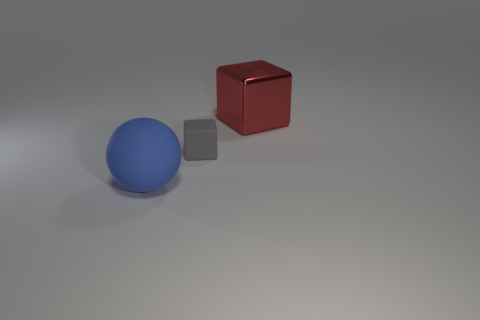Is there any other thing that is the same material as the big red block?
Offer a very short reply. No. Is there anything else that is the same size as the gray rubber cube?
Give a very brief answer. No. There is a object that is in front of the matte object that is behind the blue ball; what size is it?
Your answer should be compact. Large. Are there any big matte objects of the same color as the big cube?
Offer a very short reply. No. Are there an equal number of tiny gray matte blocks that are behind the small rubber thing and blue objects?
Keep it short and to the point. No. How many blue matte balls are there?
Give a very brief answer. 1. What is the shape of the thing that is to the left of the large shiny block and behind the blue sphere?
Ensure brevity in your answer.  Cube. There is a rubber object to the right of the big rubber sphere; is its color the same as the large object left of the big red block?
Make the answer very short. No. Are there any big red blocks that have the same material as the small gray block?
Your response must be concise. No. Are there an equal number of things that are on the left side of the metallic thing and blocks that are to the left of the sphere?
Your response must be concise. No. 